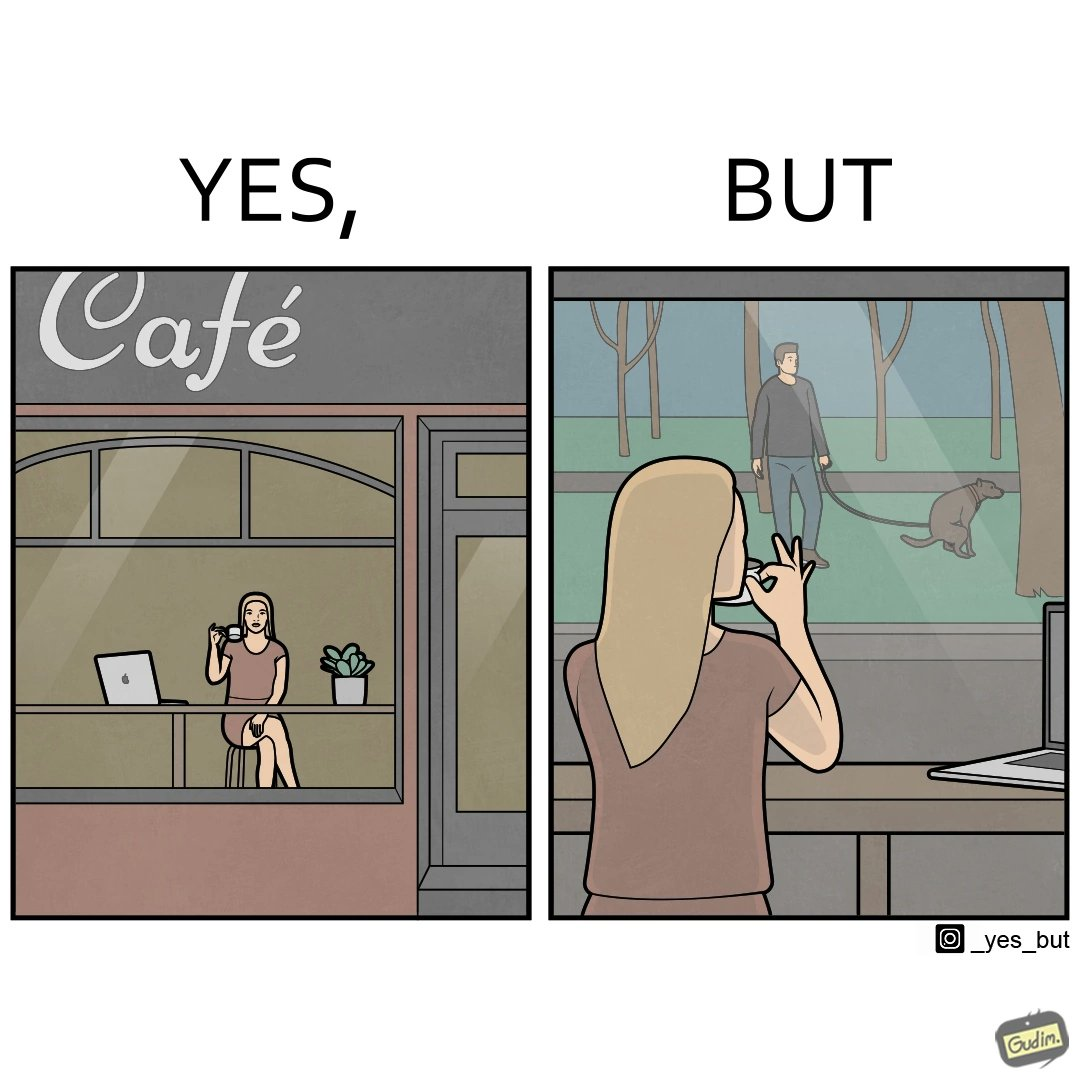What makes this image funny or satirical? The image is ironic, because in the first image the woman is seen as enjoying the view but in the second image the same woman is seen as looking at a pooping dog 